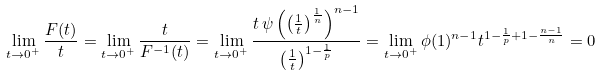<formula> <loc_0><loc_0><loc_500><loc_500>\lim _ { t \to 0 ^ { + } } \frac { F ( t ) } { t } & = \lim _ { t \to 0 ^ { + } } \frac { t } { F ^ { - 1 } ( t ) } = \lim _ { t \to 0 ^ { + } } \frac { t \, \psi \left ( \left ( \frac { 1 } { t } \right ) ^ { \frac { 1 } { n } } \right ) ^ { n - 1 } } { \left ( \frac { 1 } { t } \right ) ^ { 1 - \frac { 1 } { p } } } = \lim _ { t \to 0 ^ { + } } \phi ( 1 ) ^ { n - 1 } t ^ { 1 - \frac { 1 } { p } + 1 - \frac { n - 1 } { n } } = 0</formula> 